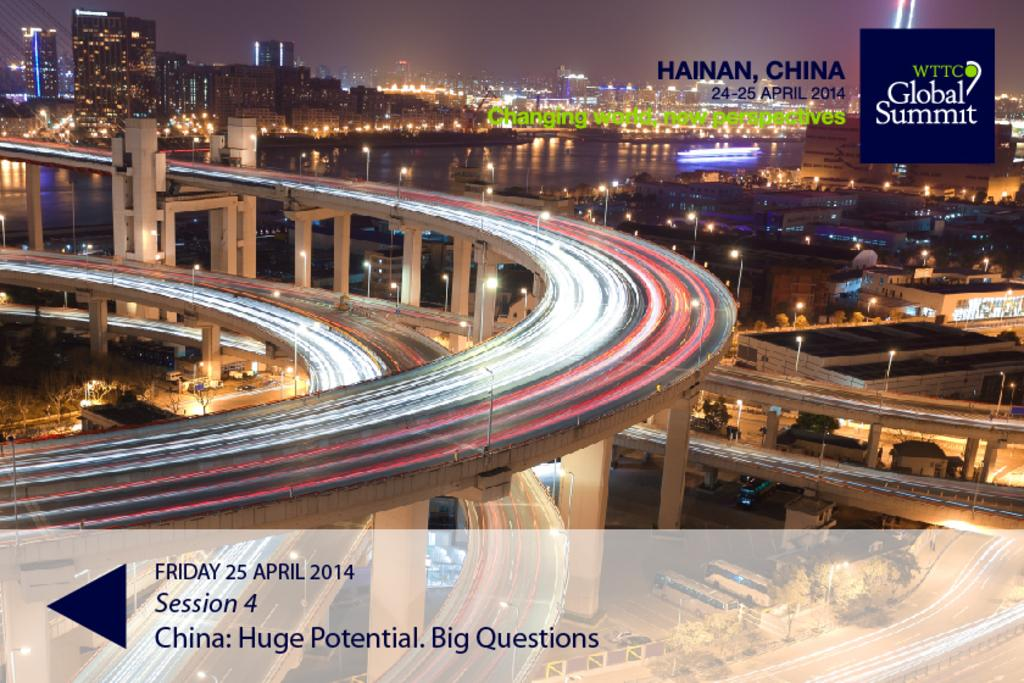What type of surface can be seen in the image? There is a road in the image. What structures are present in the image? There are buildings in the image. What can be seen illuminating the scene in the image? There are lights in the image. What part of the natural environment is visible in the image? The sky is visible in the image. How would you describe the overall lighting in the image? The image is a little dark. What type of water feature is present in the image? There is water in the image. What type of vehicle is present in the image? There is a boat in the image. What type of soap is being used to clean the boat in the image? There is no soap or cleaning activity present in the image; it only shows a boat in the water. What is the position of the boat in relation to the buildings in the image? The position of the boat cannot be determined in relation to the buildings, as the image does not provide a clear reference point for comparison. 